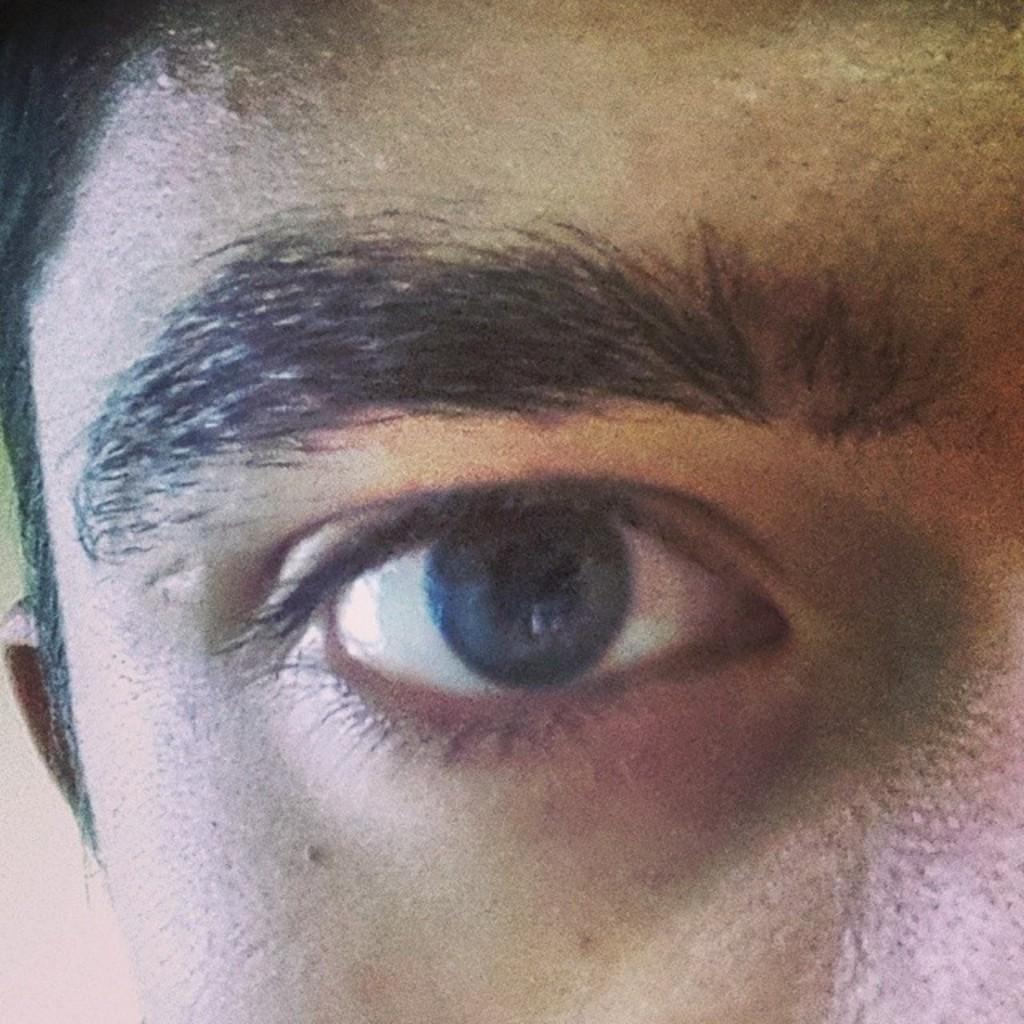What part of a person is shown in the image? There is a person's face in the image. What specific facial feature can be seen in the image? The person's eye and eyebrows are visible in the image. What type of hair is visible on the person's face in the image? There is hair visible on the left side of the person's face in the image. What other facial feature can be seen on the left side of the person's face in the image? The person's ear is visible on the left side of the face in the image. What type of appliance is visible on the person's face in the image? There is no appliance visible on the person's face in the image. What type of pan is being used to cook the person's face in the image? There is no pan or cooking involved in the image; it is a photograph of a person's face. 